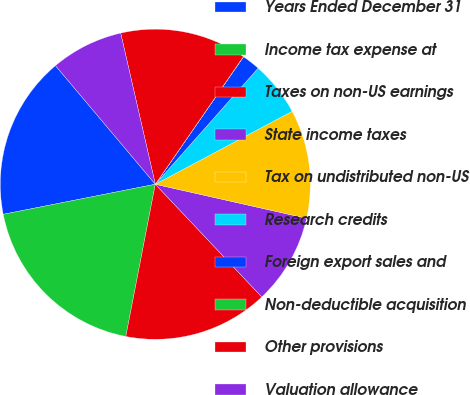Convert chart. <chart><loc_0><loc_0><loc_500><loc_500><pie_chart><fcel>Years Ended December 31<fcel>Income tax expense at<fcel>Taxes on non-US earnings<fcel>State income taxes<fcel>Tax on undistributed non-US<fcel>Research credits<fcel>Foreign export sales and<fcel>Non-deductible acquisition<fcel>Other provisions<fcel>Valuation allowance<nl><fcel>16.97%<fcel>18.85%<fcel>15.09%<fcel>9.43%<fcel>11.32%<fcel>5.67%<fcel>1.9%<fcel>0.02%<fcel>13.2%<fcel>7.55%<nl></chart> 